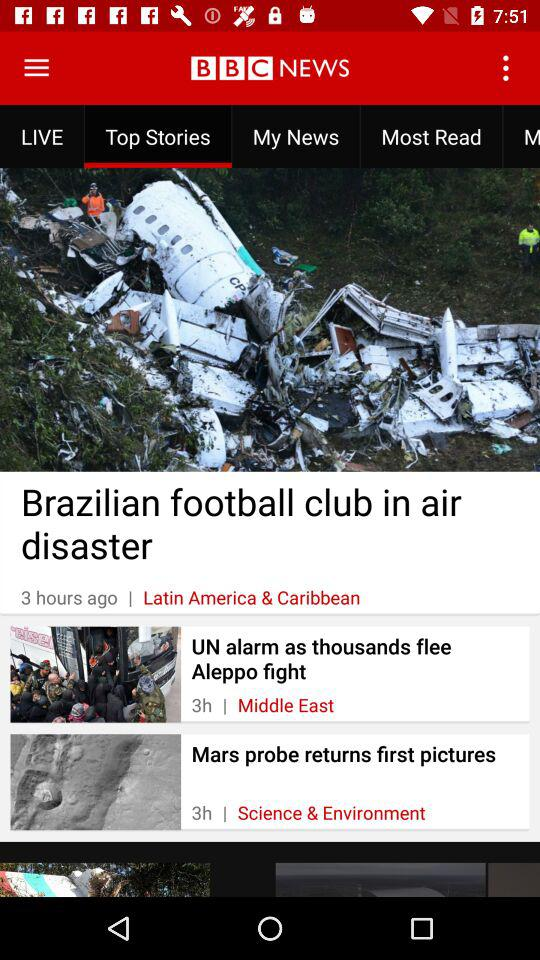How many items are there in the top stories section?
Answer the question using a single word or phrase. 3 